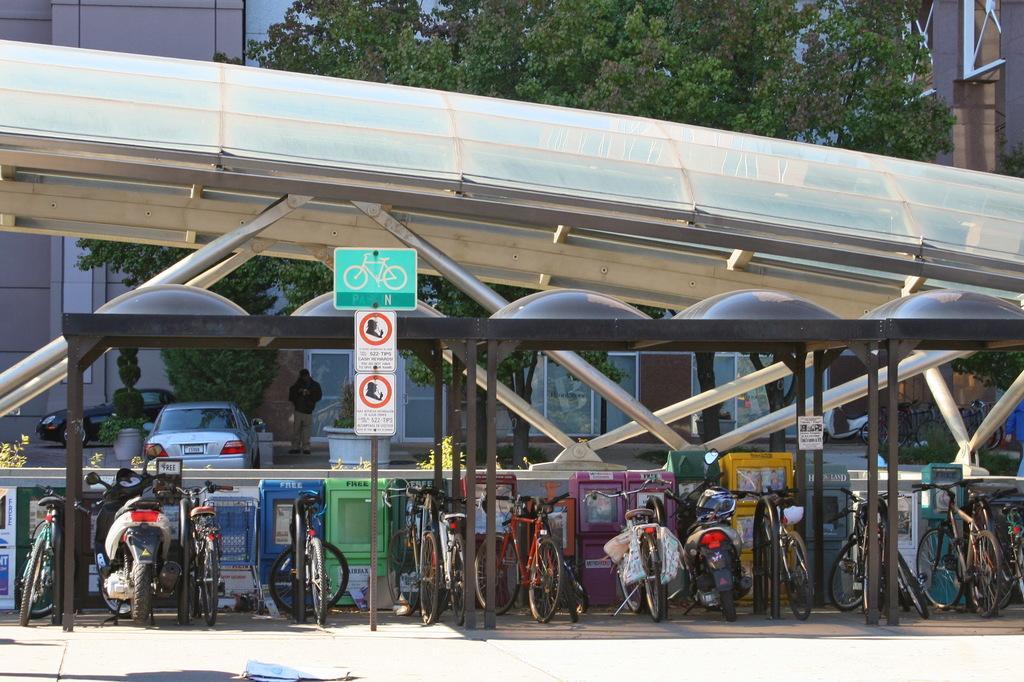Describe this image in one or two sentences. In this picture there is a cycle and scooter stand in the front of the image. Behind there is white color metal shed. In the background there are some trees and buildings. 